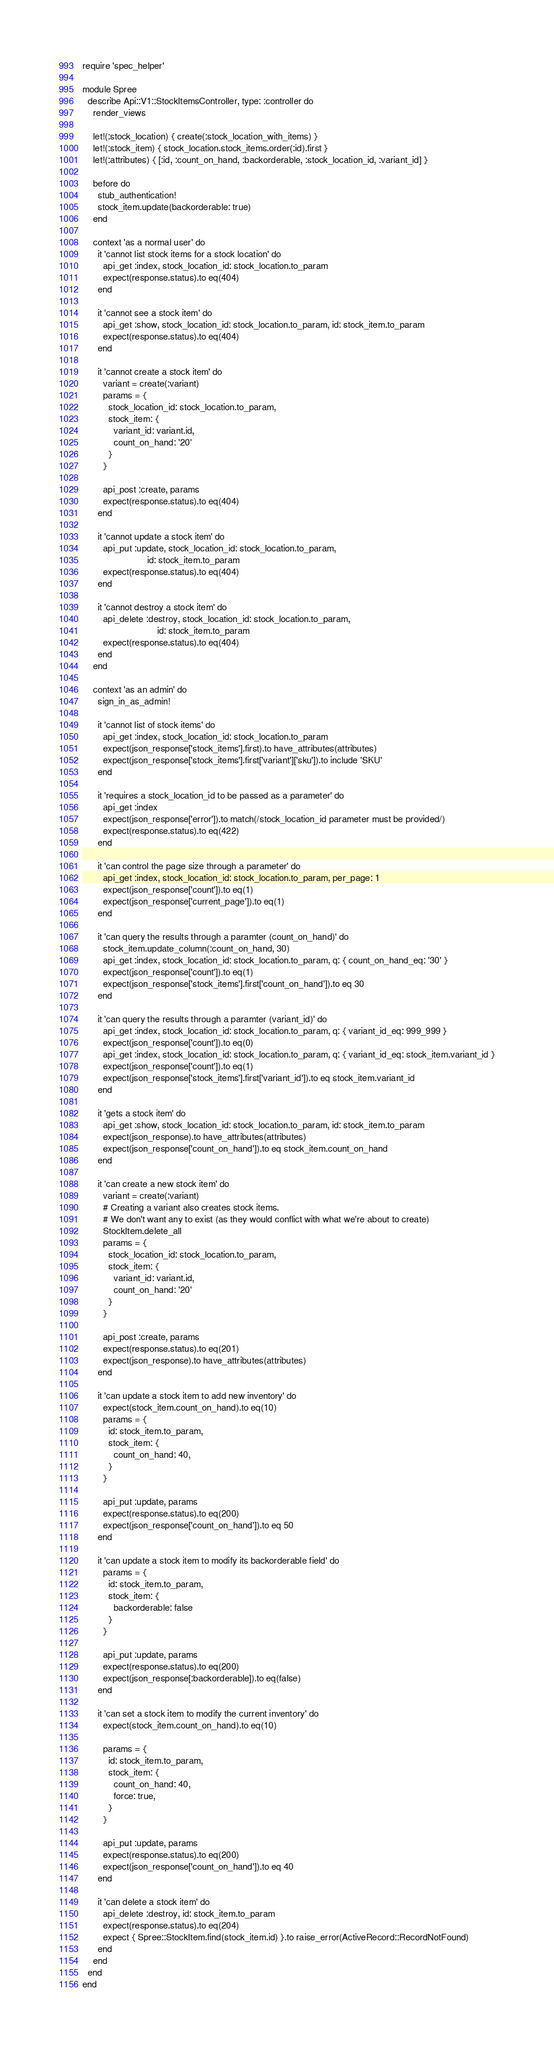<code> <loc_0><loc_0><loc_500><loc_500><_Ruby_>require 'spec_helper'

module Spree
  describe Api::V1::StockItemsController, type: :controller do
    render_views

    let!(:stock_location) { create(:stock_location_with_items) }
    let!(:stock_item) { stock_location.stock_items.order(:id).first }
    let!(:attributes) { [:id, :count_on_hand, :backorderable, :stock_location_id, :variant_id] }

    before do
      stub_authentication!
      stock_item.update(backorderable: true)
    end

    context 'as a normal user' do
      it 'cannot list stock items for a stock location' do
        api_get :index, stock_location_id: stock_location.to_param
        expect(response.status).to eq(404)
      end

      it 'cannot see a stock item' do
        api_get :show, stock_location_id: stock_location.to_param, id: stock_item.to_param
        expect(response.status).to eq(404)
      end

      it 'cannot create a stock item' do
        variant = create(:variant)
        params = {
          stock_location_id: stock_location.to_param,
          stock_item: {
            variant_id: variant.id,
            count_on_hand: '20'
          }
        }

        api_post :create, params
        expect(response.status).to eq(404)
      end

      it 'cannot update a stock item' do
        api_put :update, stock_location_id: stock_location.to_param,
                         id: stock_item.to_param
        expect(response.status).to eq(404)
      end

      it 'cannot destroy a stock item' do
        api_delete :destroy, stock_location_id: stock_location.to_param,
                             id: stock_item.to_param
        expect(response.status).to eq(404)
      end
    end

    context 'as an admin' do
      sign_in_as_admin!

      it 'cannot list of stock items' do
        api_get :index, stock_location_id: stock_location.to_param
        expect(json_response['stock_items'].first).to have_attributes(attributes)
        expect(json_response['stock_items'].first['variant']['sku']).to include 'SKU'
      end

      it 'requires a stock_location_id to be passed as a parameter' do
        api_get :index
        expect(json_response['error']).to match(/stock_location_id parameter must be provided/)
        expect(response.status).to eq(422)
      end

      it 'can control the page size through a parameter' do
        api_get :index, stock_location_id: stock_location.to_param, per_page: 1
        expect(json_response['count']).to eq(1)
        expect(json_response['current_page']).to eq(1)
      end

      it 'can query the results through a paramter (count_on_hand)' do
        stock_item.update_column(:count_on_hand, 30)
        api_get :index, stock_location_id: stock_location.to_param, q: { count_on_hand_eq: '30' }
        expect(json_response['count']).to eq(1)
        expect(json_response['stock_items'].first['count_on_hand']).to eq 30
      end

      it 'can query the results through a paramter (variant_id)' do
        api_get :index, stock_location_id: stock_location.to_param, q: { variant_id_eq: 999_999 }
        expect(json_response['count']).to eq(0)
        api_get :index, stock_location_id: stock_location.to_param, q: { variant_id_eq: stock_item.variant_id }
        expect(json_response['count']).to eq(1)
        expect(json_response['stock_items'].first['variant_id']).to eq stock_item.variant_id
      end

      it 'gets a stock item' do
        api_get :show, stock_location_id: stock_location.to_param, id: stock_item.to_param
        expect(json_response).to have_attributes(attributes)
        expect(json_response['count_on_hand']).to eq stock_item.count_on_hand
      end

      it 'can create a new stock item' do
        variant = create(:variant)
        # Creating a variant also creates stock items.
        # We don't want any to exist (as they would conflict with what we're about to create)
        StockItem.delete_all
        params = {
          stock_location_id: stock_location.to_param,
          stock_item: {
            variant_id: variant.id,
            count_on_hand: '20'
          }
        }

        api_post :create, params
        expect(response.status).to eq(201)
        expect(json_response).to have_attributes(attributes)
      end

      it 'can update a stock item to add new inventory' do
        expect(stock_item.count_on_hand).to eq(10)
        params = {
          id: stock_item.to_param,
          stock_item: {
            count_on_hand: 40,
          }
        }

        api_put :update, params
        expect(response.status).to eq(200)
        expect(json_response['count_on_hand']).to eq 50
      end

      it 'can update a stock item to modify its backorderable field' do
        params = {
          id: stock_item.to_param,
          stock_item: {
            backorderable: false
          }
        }

        api_put :update, params
        expect(response.status).to eq(200)
        expect(json_response[:backorderable]).to eq(false)
      end

      it 'can set a stock item to modify the current inventory' do
        expect(stock_item.count_on_hand).to eq(10)

        params = {
          id: stock_item.to_param,
          stock_item: {
            count_on_hand: 40,
            force: true,
          }
        }

        api_put :update, params
        expect(response.status).to eq(200)
        expect(json_response['count_on_hand']).to eq 40
      end

      it 'can delete a stock item' do
        api_delete :destroy, id: stock_item.to_param
        expect(response.status).to eq(204)
        expect { Spree::StockItem.find(stock_item.id) }.to raise_error(ActiveRecord::RecordNotFound)
      end
    end
  end
end
</code> 